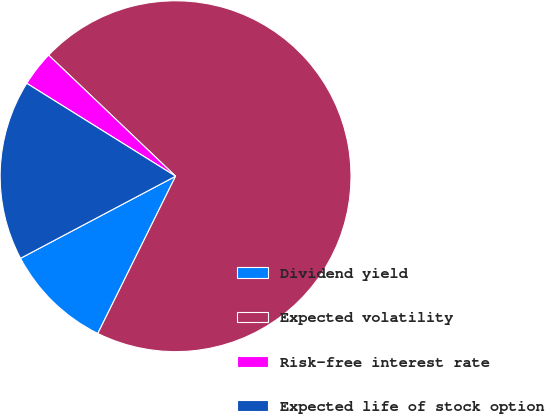Convert chart to OTSL. <chart><loc_0><loc_0><loc_500><loc_500><pie_chart><fcel>Dividend yield<fcel>Expected volatility<fcel>Risk-free interest rate<fcel>Expected life of stock option<nl><fcel>9.94%<fcel>70.19%<fcel>3.24%<fcel>16.63%<nl></chart> 